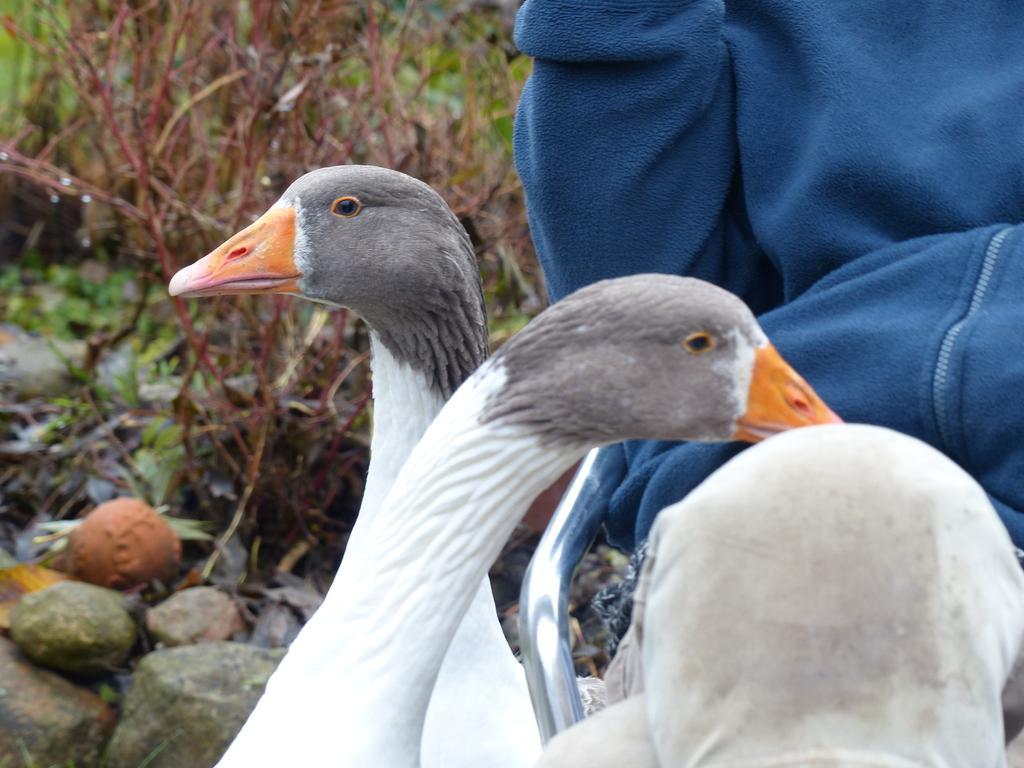Please provide a concise description of this image. In this image there are swans, person, plants, rod and rocks. Person wore a jacket. 